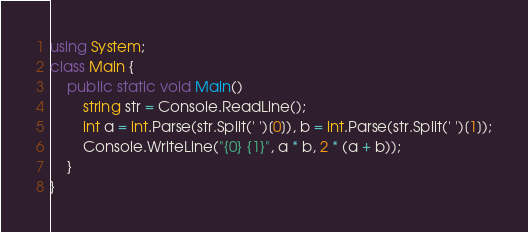Convert code to text. <code><loc_0><loc_0><loc_500><loc_500><_C#_>using System;
class Main {
    public static void Main() 
        string str = Console.ReadLine();
        int a = int.Parse(str.Split(' ')[0]), b = int.Parse(str.Split(' ')[1]);
        Console.WriteLine("{0} {1}", a * b, 2 * (a + b));
    }
}</code> 